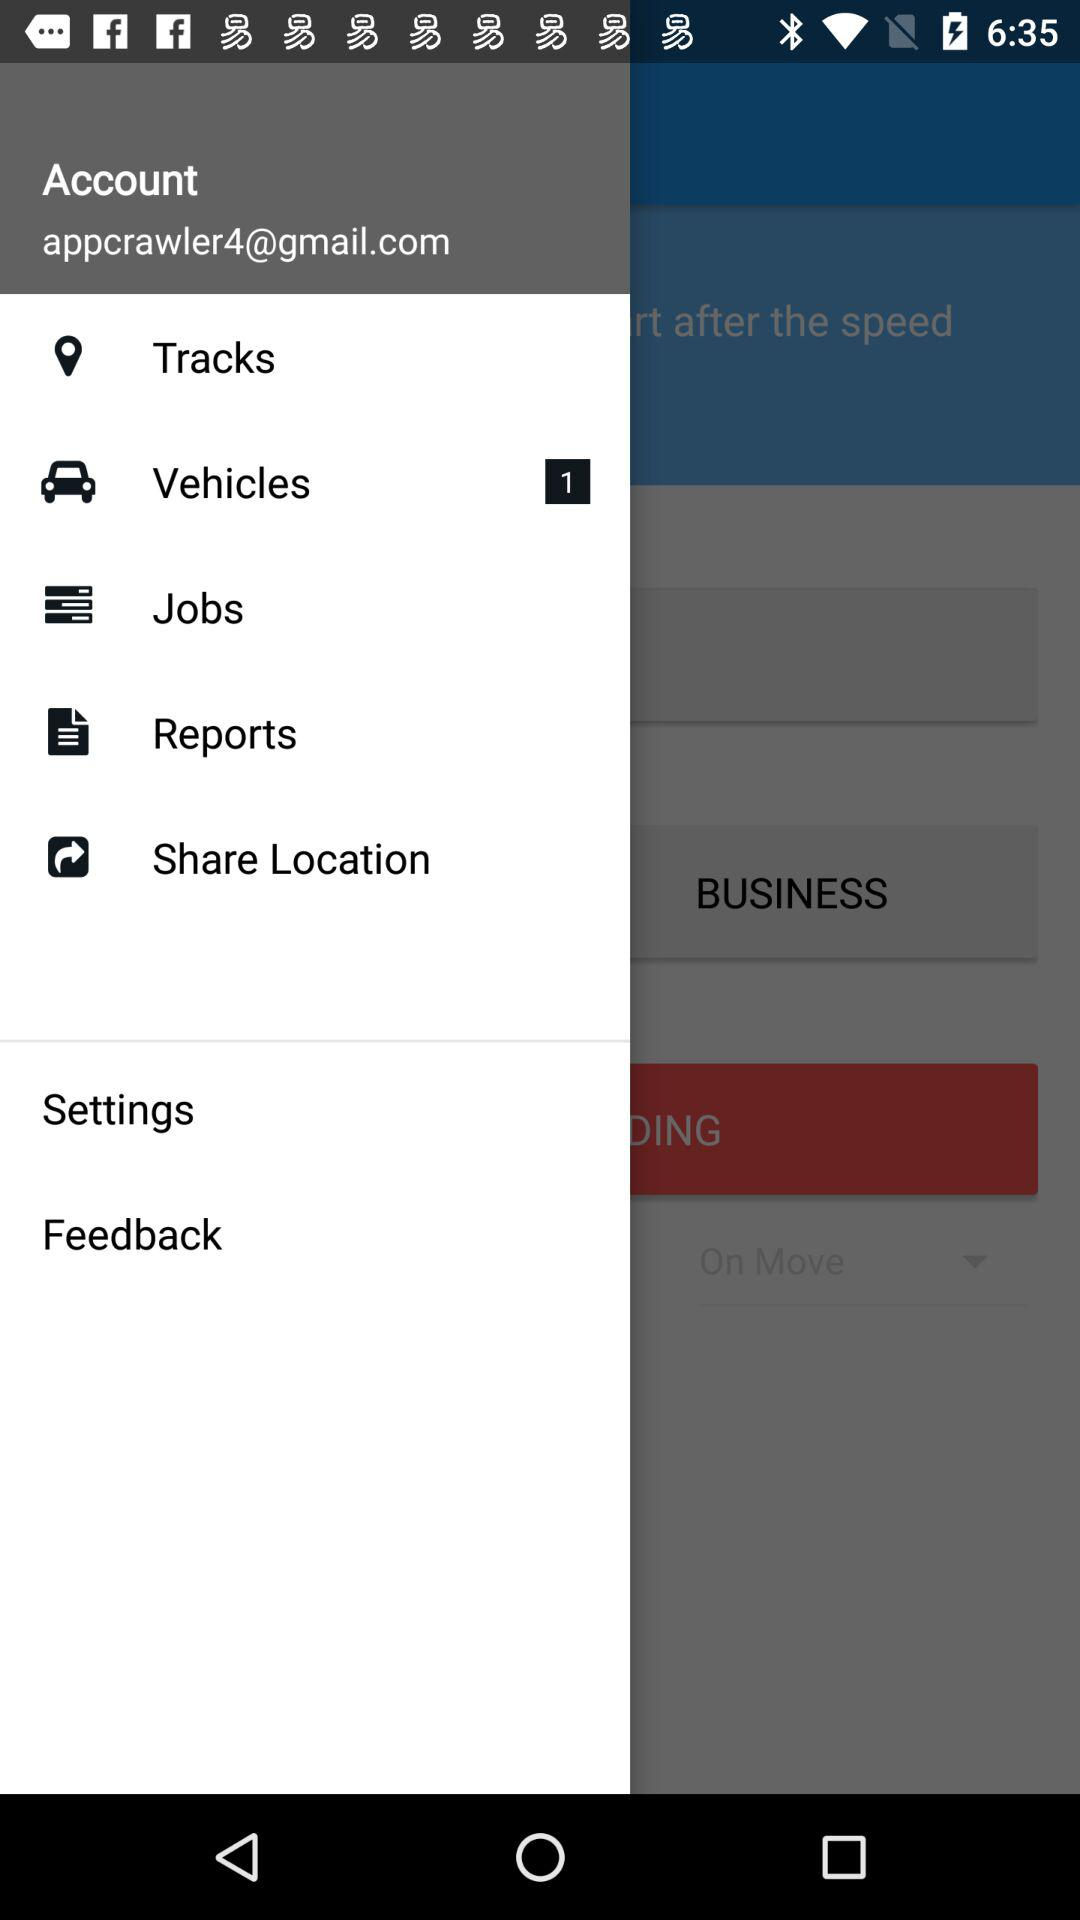How many new notifications are there on the vehicle option? There is 1 notification on the vehicle option. 